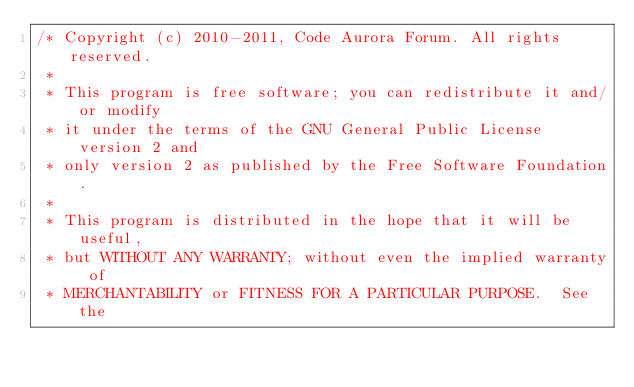<code> <loc_0><loc_0><loc_500><loc_500><_C_>/* Copyright (c) 2010-2011, Code Aurora Forum. All rights reserved.
 *
 * This program is free software; you can redistribute it and/or modify
 * it under the terms of the GNU General Public License version 2 and
 * only version 2 as published by the Free Software Foundation.
 *
 * This program is distributed in the hope that it will be useful,
 * but WITHOUT ANY WARRANTY; without even the implied warranty of
 * MERCHANTABILITY or FITNESS FOR A PARTICULAR PURPOSE.  See the</code> 